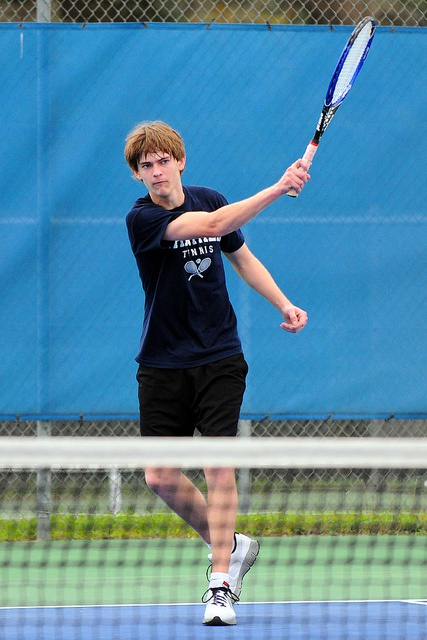Describe the objects in this image and their specific colors. I can see people in gray, black, lightpink, and lightgray tones and tennis racket in gray, lightgray, lightblue, and black tones in this image. 